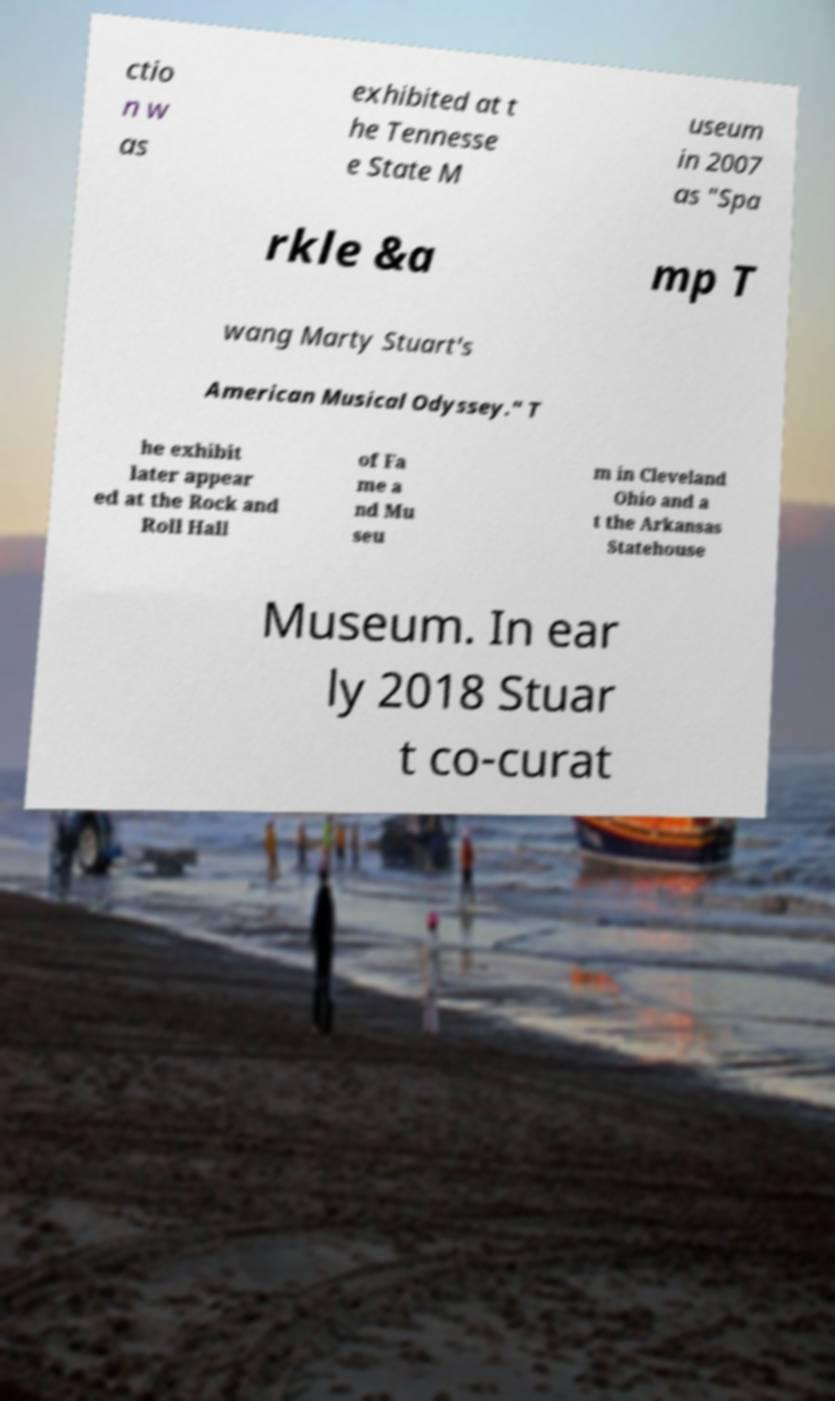Could you assist in decoding the text presented in this image and type it out clearly? ctio n w as exhibited at t he Tennesse e State M useum in 2007 as "Spa rkle &a mp T wang Marty Stuart's American Musical Odyssey." T he exhibit later appear ed at the Rock and Roll Hall of Fa me a nd Mu seu m in Cleveland Ohio and a t the Arkansas Statehouse Museum. In ear ly 2018 Stuar t co-curat 